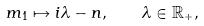<formula> <loc_0><loc_0><loc_500><loc_500>m _ { 1 } \mapsto i \lambda - n , \quad \lambda \in \mathbb { R } _ { + } ,</formula> 